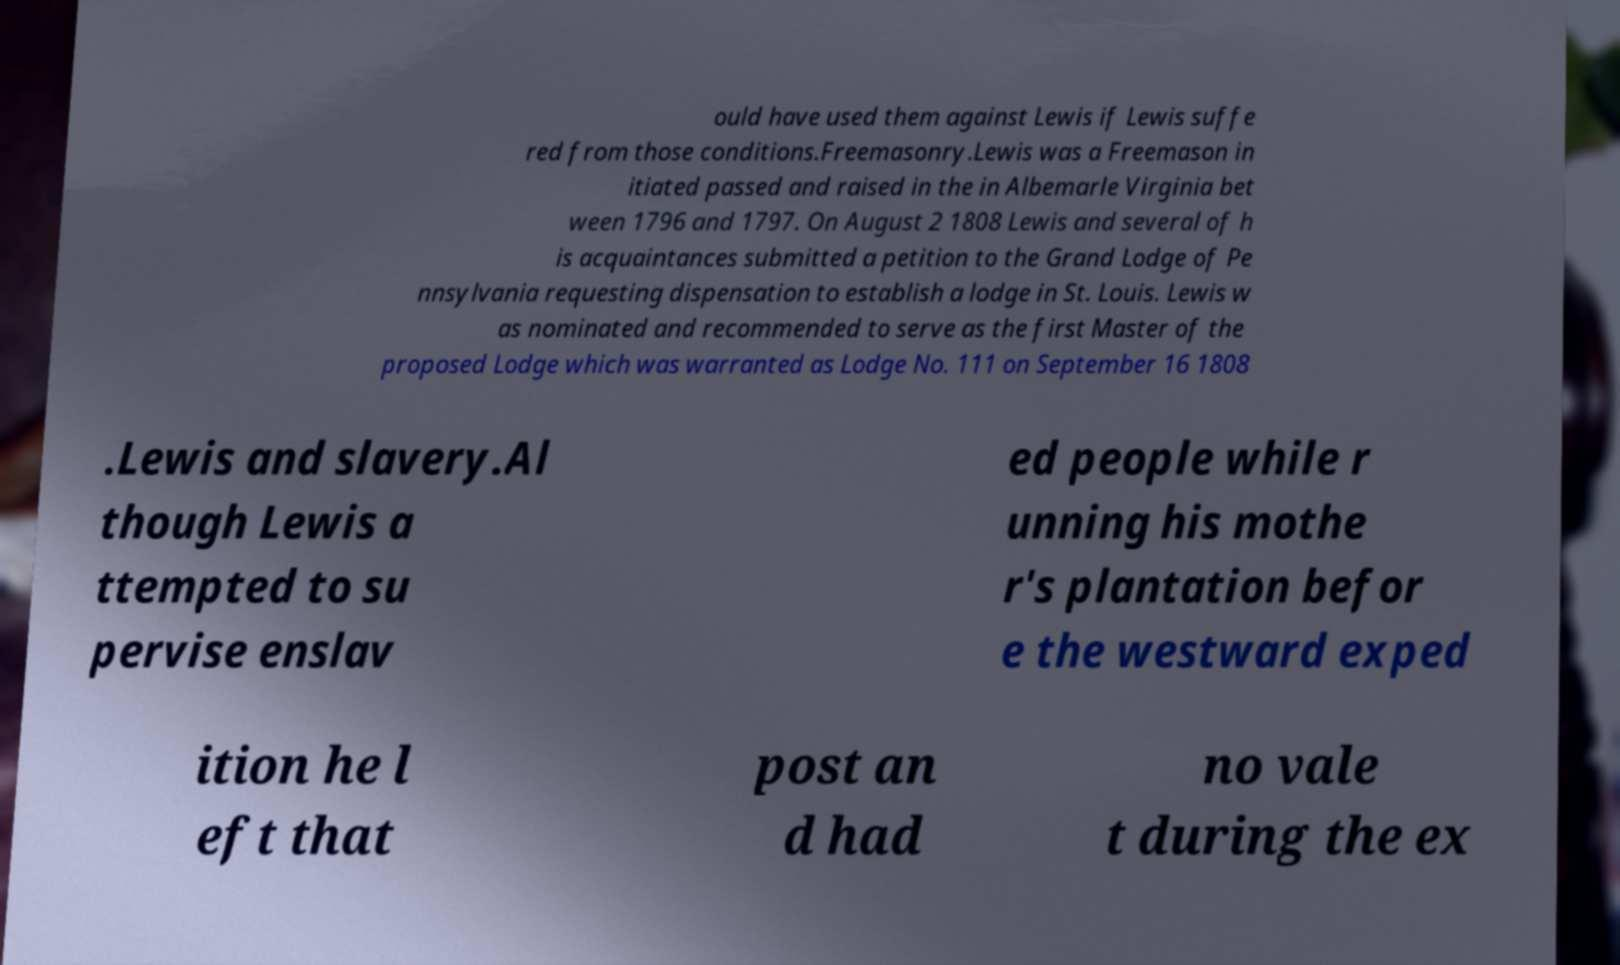For documentation purposes, I need the text within this image transcribed. Could you provide that? ould have used them against Lewis if Lewis suffe red from those conditions.Freemasonry.Lewis was a Freemason in itiated passed and raised in the in Albemarle Virginia bet ween 1796 and 1797. On August 2 1808 Lewis and several of h is acquaintances submitted a petition to the Grand Lodge of Pe nnsylvania requesting dispensation to establish a lodge in St. Louis. Lewis w as nominated and recommended to serve as the first Master of the proposed Lodge which was warranted as Lodge No. 111 on September 16 1808 .Lewis and slavery.Al though Lewis a ttempted to su pervise enslav ed people while r unning his mothe r's plantation befor e the westward exped ition he l eft that post an d had no vale t during the ex 